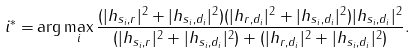<formula> <loc_0><loc_0><loc_500><loc_500>i ^ { * } = & \arg \max _ { i } \frac { ( | h _ { s _ { i } , r } | ^ { 2 } + | h _ { s _ { i } , d _ { i } } | ^ { 2 } ) ( | h _ { r , d _ { i } } | ^ { 2 } + | h _ { s _ { i } , d _ { i } } | ^ { 2 } ) | h _ { s _ { i } , d _ { i } } | ^ { 2 } } { ( | h _ { s _ { i } , r } | ^ { 2 } + | h _ { s _ { i } , d _ { i } } | ^ { 2 } ) + ( | h _ { r , d _ { i } } | ^ { 2 } + | h _ { s _ { i } , d _ { i } } | ^ { 2 } ) } .</formula> 